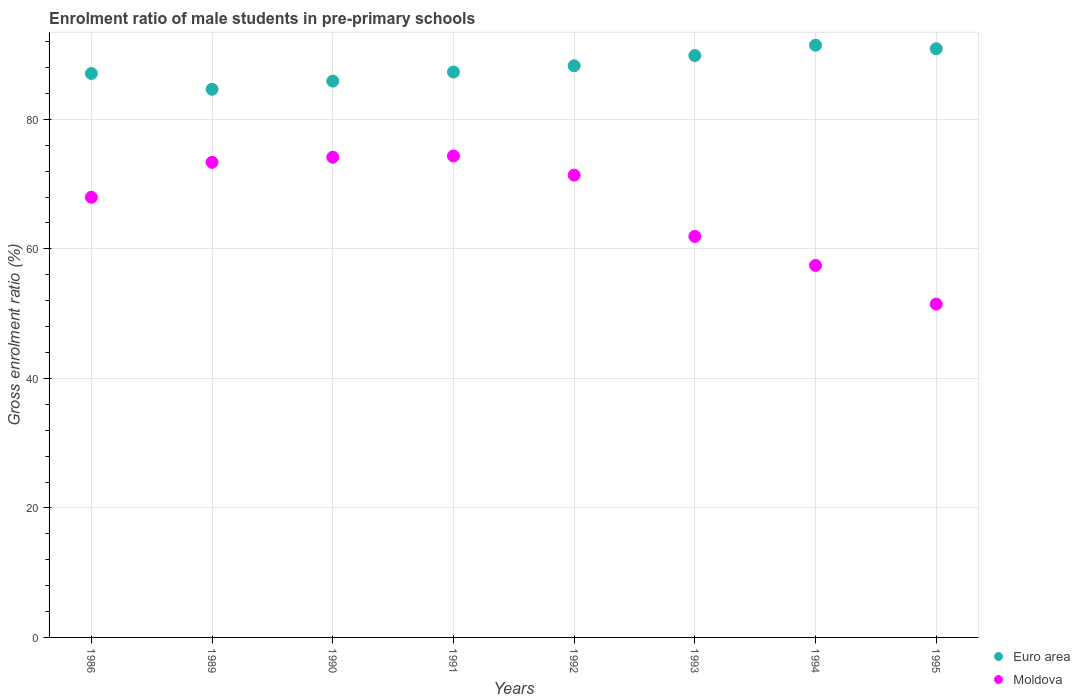How many different coloured dotlines are there?
Your response must be concise. 2. What is the enrolment ratio of male students in pre-primary schools in Euro area in 1992?
Your response must be concise. 88.28. Across all years, what is the maximum enrolment ratio of male students in pre-primary schools in Euro area?
Offer a terse response. 91.46. Across all years, what is the minimum enrolment ratio of male students in pre-primary schools in Euro area?
Your answer should be very brief. 84.65. In which year was the enrolment ratio of male students in pre-primary schools in Euro area minimum?
Provide a succinct answer. 1989. What is the total enrolment ratio of male students in pre-primary schools in Moldova in the graph?
Offer a very short reply. 532.09. What is the difference between the enrolment ratio of male students in pre-primary schools in Moldova in 1992 and that in 1995?
Ensure brevity in your answer.  19.92. What is the difference between the enrolment ratio of male students in pre-primary schools in Euro area in 1993 and the enrolment ratio of male students in pre-primary schools in Moldova in 1995?
Make the answer very short. 38.38. What is the average enrolment ratio of male students in pre-primary schools in Euro area per year?
Your response must be concise. 88.18. In the year 1993, what is the difference between the enrolment ratio of male students in pre-primary schools in Euro area and enrolment ratio of male students in pre-primary schools in Moldova?
Your response must be concise. 27.93. In how many years, is the enrolment ratio of male students in pre-primary schools in Euro area greater than 56 %?
Make the answer very short. 8. What is the ratio of the enrolment ratio of male students in pre-primary schools in Euro area in 1989 to that in 1994?
Your answer should be compact. 0.93. Is the difference between the enrolment ratio of male students in pre-primary schools in Euro area in 1991 and 1995 greater than the difference between the enrolment ratio of male students in pre-primary schools in Moldova in 1991 and 1995?
Ensure brevity in your answer.  No. What is the difference between the highest and the second highest enrolment ratio of male students in pre-primary schools in Moldova?
Keep it short and to the point. 0.2. What is the difference between the highest and the lowest enrolment ratio of male students in pre-primary schools in Moldova?
Offer a very short reply. 22.88. Is the enrolment ratio of male students in pre-primary schools in Moldova strictly greater than the enrolment ratio of male students in pre-primary schools in Euro area over the years?
Ensure brevity in your answer.  No. What is the difference between two consecutive major ticks on the Y-axis?
Provide a short and direct response. 20. Does the graph contain any zero values?
Ensure brevity in your answer.  No. Does the graph contain grids?
Your answer should be very brief. Yes. Where does the legend appear in the graph?
Offer a very short reply. Bottom right. How many legend labels are there?
Give a very brief answer. 2. How are the legend labels stacked?
Your response must be concise. Vertical. What is the title of the graph?
Offer a very short reply. Enrolment ratio of male students in pre-primary schools. Does "Oman" appear as one of the legend labels in the graph?
Your response must be concise. No. What is the label or title of the X-axis?
Give a very brief answer. Years. What is the Gross enrolment ratio (%) in Euro area in 1986?
Your answer should be compact. 87.08. What is the Gross enrolment ratio (%) in Moldova in 1986?
Offer a very short reply. 67.98. What is the Gross enrolment ratio (%) of Euro area in 1989?
Give a very brief answer. 84.65. What is the Gross enrolment ratio (%) in Moldova in 1989?
Offer a terse response. 73.37. What is the Gross enrolment ratio (%) in Euro area in 1990?
Your answer should be very brief. 85.91. What is the Gross enrolment ratio (%) of Moldova in 1990?
Provide a succinct answer. 74.15. What is the Gross enrolment ratio (%) in Euro area in 1991?
Your answer should be very brief. 87.31. What is the Gross enrolment ratio (%) of Moldova in 1991?
Make the answer very short. 74.35. What is the Gross enrolment ratio (%) in Euro area in 1992?
Your answer should be very brief. 88.28. What is the Gross enrolment ratio (%) of Moldova in 1992?
Give a very brief answer. 71.39. What is the Gross enrolment ratio (%) of Euro area in 1993?
Provide a succinct answer. 89.86. What is the Gross enrolment ratio (%) in Moldova in 1993?
Ensure brevity in your answer.  61.93. What is the Gross enrolment ratio (%) of Euro area in 1994?
Make the answer very short. 91.46. What is the Gross enrolment ratio (%) of Moldova in 1994?
Your answer should be very brief. 57.45. What is the Gross enrolment ratio (%) in Euro area in 1995?
Keep it short and to the point. 90.91. What is the Gross enrolment ratio (%) in Moldova in 1995?
Keep it short and to the point. 51.47. Across all years, what is the maximum Gross enrolment ratio (%) of Euro area?
Your response must be concise. 91.46. Across all years, what is the maximum Gross enrolment ratio (%) in Moldova?
Provide a short and direct response. 74.35. Across all years, what is the minimum Gross enrolment ratio (%) in Euro area?
Offer a terse response. 84.65. Across all years, what is the minimum Gross enrolment ratio (%) in Moldova?
Provide a succinct answer. 51.47. What is the total Gross enrolment ratio (%) of Euro area in the graph?
Provide a succinct answer. 705.46. What is the total Gross enrolment ratio (%) of Moldova in the graph?
Make the answer very short. 532.09. What is the difference between the Gross enrolment ratio (%) of Euro area in 1986 and that in 1989?
Provide a succinct answer. 2.44. What is the difference between the Gross enrolment ratio (%) of Moldova in 1986 and that in 1989?
Your response must be concise. -5.39. What is the difference between the Gross enrolment ratio (%) in Euro area in 1986 and that in 1990?
Your answer should be compact. 1.17. What is the difference between the Gross enrolment ratio (%) of Moldova in 1986 and that in 1990?
Provide a succinct answer. -6.18. What is the difference between the Gross enrolment ratio (%) of Euro area in 1986 and that in 1991?
Your answer should be compact. -0.23. What is the difference between the Gross enrolment ratio (%) of Moldova in 1986 and that in 1991?
Provide a short and direct response. -6.38. What is the difference between the Gross enrolment ratio (%) of Euro area in 1986 and that in 1992?
Your answer should be compact. -1.2. What is the difference between the Gross enrolment ratio (%) in Moldova in 1986 and that in 1992?
Your answer should be compact. -3.42. What is the difference between the Gross enrolment ratio (%) of Euro area in 1986 and that in 1993?
Your answer should be compact. -2.77. What is the difference between the Gross enrolment ratio (%) of Moldova in 1986 and that in 1993?
Your response must be concise. 6.05. What is the difference between the Gross enrolment ratio (%) in Euro area in 1986 and that in 1994?
Make the answer very short. -4.37. What is the difference between the Gross enrolment ratio (%) of Moldova in 1986 and that in 1994?
Offer a very short reply. 10.53. What is the difference between the Gross enrolment ratio (%) of Euro area in 1986 and that in 1995?
Make the answer very short. -3.83. What is the difference between the Gross enrolment ratio (%) in Moldova in 1986 and that in 1995?
Provide a succinct answer. 16.5. What is the difference between the Gross enrolment ratio (%) in Euro area in 1989 and that in 1990?
Provide a succinct answer. -1.26. What is the difference between the Gross enrolment ratio (%) in Moldova in 1989 and that in 1990?
Provide a succinct answer. -0.79. What is the difference between the Gross enrolment ratio (%) of Euro area in 1989 and that in 1991?
Offer a very short reply. -2.66. What is the difference between the Gross enrolment ratio (%) in Moldova in 1989 and that in 1991?
Provide a succinct answer. -0.98. What is the difference between the Gross enrolment ratio (%) in Euro area in 1989 and that in 1992?
Offer a terse response. -3.63. What is the difference between the Gross enrolment ratio (%) in Moldova in 1989 and that in 1992?
Provide a short and direct response. 1.98. What is the difference between the Gross enrolment ratio (%) in Euro area in 1989 and that in 1993?
Provide a succinct answer. -5.21. What is the difference between the Gross enrolment ratio (%) of Moldova in 1989 and that in 1993?
Provide a succinct answer. 11.44. What is the difference between the Gross enrolment ratio (%) of Euro area in 1989 and that in 1994?
Your response must be concise. -6.81. What is the difference between the Gross enrolment ratio (%) in Moldova in 1989 and that in 1994?
Your answer should be very brief. 15.92. What is the difference between the Gross enrolment ratio (%) in Euro area in 1989 and that in 1995?
Your answer should be compact. -6.26. What is the difference between the Gross enrolment ratio (%) in Moldova in 1989 and that in 1995?
Offer a terse response. 21.9. What is the difference between the Gross enrolment ratio (%) of Euro area in 1990 and that in 1991?
Your answer should be very brief. -1.4. What is the difference between the Gross enrolment ratio (%) in Moldova in 1990 and that in 1991?
Your response must be concise. -0.2. What is the difference between the Gross enrolment ratio (%) of Euro area in 1990 and that in 1992?
Give a very brief answer. -2.37. What is the difference between the Gross enrolment ratio (%) in Moldova in 1990 and that in 1992?
Give a very brief answer. 2.76. What is the difference between the Gross enrolment ratio (%) of Euro area in 1990 and that in 1993?
Ensure brevity in your answer.  -3.95. What is the difference between the Gross enrolment ratio (%) in Moldova in 1990 and that in 1993?
Give a very brief answer. 12.23. What is the difference between the Gross enrolment ratio (%) in Euro area in 1990 and that in 1994?
Keep it short and to the point. -5.55. What is the difference between the Gross enrolment ratio (%) in Moldova in 1990 and that in 1994?
Your answer should be compact. 16.7. What is the difference between the Gross enrolment ratio (%) in Euro area in 1990 and that in 1995?
Ensure brevity in your answer.  -5. What is the difference between the Gross enrolment ratio (%) in Moldova in 1990 and that in 1995?
Provide a short and direct response. 22.68. What is the difference between the Gross enrolment ratio (%) in Euro area in 1991 and that in 1992?
Offer a terse response. -0.97. What is the difference between the Gross enrolment ratio (%) of Moldova in 1991 and that in 1992?
Give a very brief answer. 2.96. What is the difference between the Gross enrolment ratio (%) of Euro area in 1991 and that in 1993?
Your response must be concise. -2.55. What is the difference between the Gross enrolment ratio (%) in Moldova in 1991 and that in 1993?
Offer a very short reply. 12.43. What is the difference between the Gross enrolment ratio (%) of Euro area in 1991 and that in 1994?
Your answer should be very brief. -4.14. What is the difference between the Gross enrolment ratio (%) of Moldova in 1991 and that in 1994?
Provide a succinct answer. 16.9. What is the difference between the Gross enrolment ratio (%) of Euro area in 1991 and that in 1995?
Ensure brevity in your answer.  -3.6. What is the difference between the Gross enrolment ratio (%) in Moldova in 1991 and that in 1995?
Ensure brevity in your answer.  22.88. What is the difference between the Gross enrolment ratio (%) of Euro area in 1992 and that in 1993?
Provide a short and direct response. -1.58. What is the difference between the Gross enrolment ratio (%) of Moldova in 1992 and that in 1993?
Offer a very short reply. 9.47. What is the difference between the Gross enrolment ratio (%) of Euro area in 1992 and that in 1994?
Your answer should be compact. -3.18. What is the difference between the Gross enrolment ratio (%) of Moldova in 1992 and that in 1994?
Offer a terse response. 13.94. What is the difference between the Gross enrolment ratio (%) in Euro area in 1992 and that in 1995?
Provide a short and direct response. -2.63. What is the difference between the Gross enrolment ratio (%) of Moldova in 1992 and that in 1995?
Your response must be concise. 19.92. What is the difference between the Gross enrolment ratio (%) of Euro area in 1993 and that in 1994?
Keep it short and to the point. -1.6. What is the difference between the Gross enrolment ratio (%) of Moldova in 1993 and that in 1994?
Provide a short and direct response. 4.48. What is the difference between the Gross enrolment ratio (%) in Euro area in 1993 and that in 1995?
Offer a terse response. -1.05. What is the difference between the Gross enrolment ratio (%) in Moldova in 1993 and that in 1995?
Offer a terse response. 10.45. What is the difference between the Gross enrolment ratio (%) of Euro area in 1994 and that in 1995?
Give a very brief answer. 0.54. What is the difference between the Gross enrolment ratio (%) of Moldova in 1994 and that in 1995?
Your answer should be compact. 5.98. What is the difference between the Gross enrolment ratio (%) in Euro area in 1986 and the Gross enrolment ratio (%) in Moldova in 1989?
Give a very brief answer. 13.71. What is the difference between the Gross enrolment ratio (%) of Euro area in 1986 and the Gross enrolment ratio (%) of Moldova in 1990?
Your response must be concise. 12.93. What is the difference between the Gross enrolment ratio (%) in Euro area in 1986 and the Gross enrolment ratio (%) in Moldova in 1991?
Ensure brevity in your answer.  12.73. What is the difference between the Gross enrolment ratio (%) of Euro area in 1986 and the Gross enrolment ratio (%) of Moldova in 1992?
Offer a very short reply. 15.69. What is the difference between the Gross enrolment ratio (%) of Euro area in 1986 and the Gross enrolment ratio (%) of Moldova in 1993?
Your answer should be compact. 25.16. What is the difference between the Gross enrolment ratio (%) in Euro area in 1986 and the Gross enrolment ratio (%) in Moldova in 1994?
Keep it short and to the point. 29.63. What is the difference between the Gross enrolment ratio (%) in Euro area in 1986 and the Gross enrolment ratio (%) in Moldova in 1995?
Offer a very short reply. 35.61. What is the difference between the Gross enrolment ratio (%) in Euro area in 1989 and the Gross enrolment ratio (%) in Moldova in 1990?
Keep it short and to the point. 10.49. What is the difference between the Gross enrolment ratio (%) in Euro area in 1989 and the Gross enrolment ratio (%) in Moldova in 1991?
Offer a terse response. 10.3. What is the difference between the Gross enrolment ratio (%) in Euro area in 1989 and the Gross enrolment ratio (%) in Moldova in 1992?
Your answer should be very brief. 13.26. What is the difference between the Gross enrolment ratio (%) of Euro area in 1989 and the Gross enrolment ratio (%) of Moldova in 1993?
Provide a short and direct response. 22.72. What is the difference between the Gross enrolment ratio (%) in Euro area in 1989 and the Gross enrolment ratio (%) in Moldova in 1994?
Offer a terse response. 27.2. What is the difference between the Gross enrolment ratio (%) of Euro area in 1989 and the Gross enrolment ratio (%) of Moldova in 1995?
Your response must be concise. 33.17. What is the difference between the Gross enrolment ratio (%) of Euro area in 1990 and the Gross enrolment ratio (%) of Moldova in 1991?
Your answer should be very brief. 11.56. What is the difference between the Gross enrolment ratio (%) of Euro area in 1990 and the Gross enrolment ratio (%) of Moldova in 1992?
Offer a terse response. 14.52. What is the difference between the Gross enrolment ratio (%) in Euro area in 1990 and the Gross enrolment ratio (%) in Moldova in 1993?
Ensure brevity in your answer.  23.98. What is the difference between the Gross enrolment ratio (%) in Euro area in 1990 and the Gross enrolment ratio (%) in Moldova in 1994?
Make the answer very short. 28.46. What is the difference between the Gross enrolment ratio (%) in Euro area in 1990 and the Gross enrolment ratio (%) in Moldova in 1995?
Your response must be concise. 34.44. What is the difference between the Gross enrolment ratio (%) in Euro area in 1991 and the Gross enrolment ratio (%) in Moldova in 1992?
Offer a terse response. 15.92. What is the difference between the Gross enrolment ratio (%) of Euro area in 1991 and the Gross enrolment ratio (%) of Moldova in 1993?
Give a very brief answer. 25.39. What is the difference between the Gross enrolment ratio (%) in Euro area in 1991 and the Gross enrolment ratio (%) in Moldova in 1994?
Provide a succinct answer. 29.86. What is the difference between the Gross enrolment ratio (%) of Euro area in 1991 and the Gross enrolment ratio (%) of Moldova in 1995?
Provide a succinct answer. 35.84. What is the difference between the Gross enrolment ratio (%) in Euro area in 1992 and the Gross enrolment ratio (%) in Moldova in 1993?
Provide a succinct answer. 26.35. What is the difference between the Gross enrolment ratio (%) in Euro area in 1992 and the Gross enrolment ratio (%) in Moldova in 1994?
Give a very brief answer. 30.83. What is the difference between the Gross enrolment ratio (%) of Euro area in 1992 and the Gross enrolment ratio (%) of Moldova in 1995?
Ensure brevity in your answer.  36.81. What is the difference between the Gross enrolment ratio (%) in Euro area in 1993 and the Gross enrolment ratio (%) in Moldova in 1994?
Keep it short and to the point. 32.41. What is the difference between the Gross enrolment ratio (%) of Euro area in 1993 and the Gross enrolment ratio (%) of Moldova in 1995?
Ensure brevity in your answer.  38.38. What is the difference between the Gross enrolment ratio (%) in Euro area in 1994 and the Gross enrolment ratio (%) in Moldova in 1995?
Give a very brief answer. 39.98. What is the average Gross enrolment ratio (%) of Euro area per year?
Keep it short and to the point. 88.18. What is the average Gross enrolment ratio (%) of Moldova per year?
Your answer should be compact. 66.51. In the year 1986, what is the difference between the Gross enrolment ratio (%) in Euro area and Gross enrolment ratio (%) in Moldova?
Give a very brief answer. 19.11. In the year 1989, what is the difference between the Gross enrolment ratio (%) of Euro area and Gross enrolment ratio (%) of Moldova?
Ensure brevity in your answer.  11.28. In the year 1990, what is the difference between the Gross enrolment ratio (%) of Euro area and Gross enrolment ratio (%) of Moldova?
Your response must be concise. 11.76. In the year 1991, what is the difference between the Gross enrolment ratio (%) of Euro area and Gross enrolment ratio (%) of Moldova?
Your response must be concise. 12.96. In the year 1992, what is the difference between the Gross enrolment ratio (%) in Euro area and Gross enrolment ratio (%) in Moldova?
Ensure brevity in your answer.  16.89. In the year 1993, what is the difference between the Gross enrolment ratio (%) in Euro area and Gross enrolment ratio (%) in Moldova?
Keep it short and to the point. 27.93. In the year 1994, what is the difference between the Gross enrolment ratio (%) of Euro area and Gross enrolment ratio (%) of Moldova?
Provide a succinct answer. 34.01. In the year 1995, what is the difference between the Gross enrolment ratio (%) in Euro area and Gross enrolment ratio (%) in Moldova?
Your answer should be compact. 39.44. What is the ratio of the Gross enrolment ratio (%) of Euro area in 1986 to that in 1989?
Offer a terse response. 1.03. What is the ratio of the Gross enrolment ratio (%) of Moldova in 1986 to that in 1989?
Offer a very short reply. 0.93. What is the ratio of the Gross enrolment ratio (%) of Euro area in 1986 to that in 1990?
Your answer should be compact. 1.01. What is the ratio of the Gross enrolment ratio (%) in Moldova in 1986 to that in 1990?
Your answer should be compact. 0.92. What is the ratio of the Gross enrolment ratio (%) in Moldova in 1986 to that in 1991?
Your answer should be compact. 0.91. What is the ratio of the Gross enrolment ratio (%) in Euro area in 1986 to that in 1992?
Give a very brief answer. 0.99. What is the ratio of the Gross enrolment ratio (%) of Moldova in 1986 to that in 1992?
Offer a terse response. 0.95. What is the ratio of the Gross enrolment ratio (%) in Euro area in 1986 to that in 1993?
Your response must be concise. 0.97. What is the ratio of the Gross enrolment ratio (%) in Moldova in 1986 to that in 1993?
Ensure brevity in your answer.  1.1. What is the ratio of the Gross enrolment ratio (%) in Euro area in 1986 to that in 1994?
Provide a succinct answer. 0.95. What is the ratio of the Gross enrolment ratio (%) of Moldova in 1986 to that in 1994?
Your response must be concise. 1.18. What is the ratio of the Gross enrolment ratio (%) of Euro area in 1986 to that in 1995?
Give a very brief answer. 0.96. What is the ratio of the Gross enrolment ratio (%) of Moldova in 1986 to that in 1995?
Keep it short and to the point. 1.32. What is the ratio of the Gross enrolment ratio (%) in Euro area in 1989 to that in 1991?
Give a very brief answer. 0.97. What is the ratio of the Gross enrolment ratio (%) of Euro area in 1989 to that in 1992?
Make the answer very short. 0.96. What is the ratio of the Gross enrolment ratio (%) in Moldova in 1989 to that in 1992?
Your answer should be very brief. 1.03. What is the ratio of the Gross enrolment ratio (%) of Euro area in 1989 to that in 1993?
Your answer should be compact. 0.94. What is the ratio of the Gross enrolment ratio (%) in Moldova in 1989 to that in 1993?
Offer a very short reply. 1.18. What is the ratio of the Gross enrolment ratio (%) in Euro area in 1989 to that in 1994?
Provide a short and direct response. 0.93. What is the ratio of the Gross enrolment ratio (%) of Moldova in 1989 to that in 1994?
Keep it short and to the point. 1.28. What is the ratio of the Gross enrolment ratio (%) of Euro area in 1989 to that in 1995?
Ensure brevity in your answer.  0.93. What is the ratio of the Gross enrolment ratio (%) of Moldova in 1989 to that in 1995?
Provide a succinct answer. 1.43. What is the ratio of the Gross enrolment ratio (%) in Euro area in 1990 to that in 1991?
Your response must be concise. 0.98. What is the ratio of the Gross enrolment ratio (%) of Moldova in 1990 to that in 1991?
Keep it short and to the point. 1. What is the ratio of the Gross enrolment ratio (%) in Euro area in 1990 to that in 1992?
Keep it short and to the point. 0.97. What is the ratio of the Gross enrolment ratio (%) of Moldova in 1990 to that in 1992?
Offer a terse response. 1.04. What is the ratio of the Gross enrolment ratio (%) in Euro area in 1990 to that in 1993?
Your answer should be compact. 0.96. What is the ratio of the Gross enrolment ratio (%) in Moldova in 1990 to that in 1993?
Provide a short and direct response. 1.2. What is the ratio of the Gross enrolment ratio (%) of Euro area in 1990 to that in 1994?
Keep it short and to the point. 0.94. What is the ratio of the Gross enrolment ratio (%) of Moldova in 1990 to that in 1994?
Offer a very short reply. 1.29. What is the ratio of the Gross enrolment ratio (%) in Euro area in 1990 to that in 1995?
Make the answer very short. 0.94. What is the ratio of the Gross enrolment ratio (%) of Moldova in 1990 to that in 1995?
Keep it short and to the point. 1.44. What is the ratio of the Gross enrolment ratio (%) of Moldova in 1991 to that in 1992?
Make the answer very short. 1.04. What is the ratio of the Gross enrolment ratio (%) of Euro area in 1991 to that in 1993?
Offer a terse response. 0.97. What is the ratio of the Gross enrolment ratio (%) in Moldova in 1991 to that in 1993?
Keep it short and to the point. 1.2. What is the ratio of the Gross enrolment ratio (%) in Euro area in 1991 to that in 1994?
Provide a short and direct response. 0.95. What is the ratio of the Gross enrolment ratio (%) of Moldova in 1991 to that in 1994?
Keep it short and to the point. 1.29. What is the ratio of the Gross enrolment ratio (%) in Euro area in 1991 to that in 1995?
Provide a succinct answer. 0.96. What is the ratio of the Gross enrolment ratio (%) in Moldova in 1991 to that in 1995?
Your response must be concise. 1.44. What is the ratio of the Gross enrolment ratio (%) in Euro area in 1992 to that in 1993?
Provide a short and direct response. 0.98. What is the ratio of the Gross enrolment ratio (%) in Moldova in 1992 to that in 1993?
Your answer should be very brief. 1.15. What is the ratio of the Gross enrolment ratio (%) of Euro area in 1992 to that in 1994?
Give a very brief answer. 0.97. What is the ratio of the Gross enrolment ratio (%) in Moldova in 1992 to that in 1994?
Offer a very short reply. 1.24. What is the ratio of the Gross enrolment ratio (%) of Moldova in 1992 to that in 1995?
Make the answer very short. 1.39. What is the ratio of the Gross enrolment ratio (%) of Euro area in 1993 to that in 1994?
Your response must be concise. 0.98. What is the ratio of the Gross enrolment ratio (%) in Moldova in 1993 to that in 1994?
Provide a short and direct response. 1.08. What is the ratio of the Gross enrolment ratio (%) in Euro area in 1993 to that in 1995?
Offer a terse response. 0.99. What is the ratio of the Gross enrolment ratio (%) of Moldova in 1993 to that in 1995?
Make the answer very short. 1.2. What is the ratio of the Gross enrolment ratio (%) of Moldova in 1994 to that in 1995?
Keep it short and to the point. 1.12. What is the difference between the highest and the second highest Gross enrolment ratio (%) in Euro area?
Your answer should be very brief. 0.54. What is the difference between the highest and the second highest Gross enrolment ratio (%) in Moldova?
Make the answer very short. 0.2. What is the difference between the highest and the lowest Gross enrolment ratio (%) of Euro area?
Make the answer very short. 6.81. What is the difference between the highest and the lowest Gross enrolment ratio (%) of Moldova?
Your answer should be very brief. 22.88. 